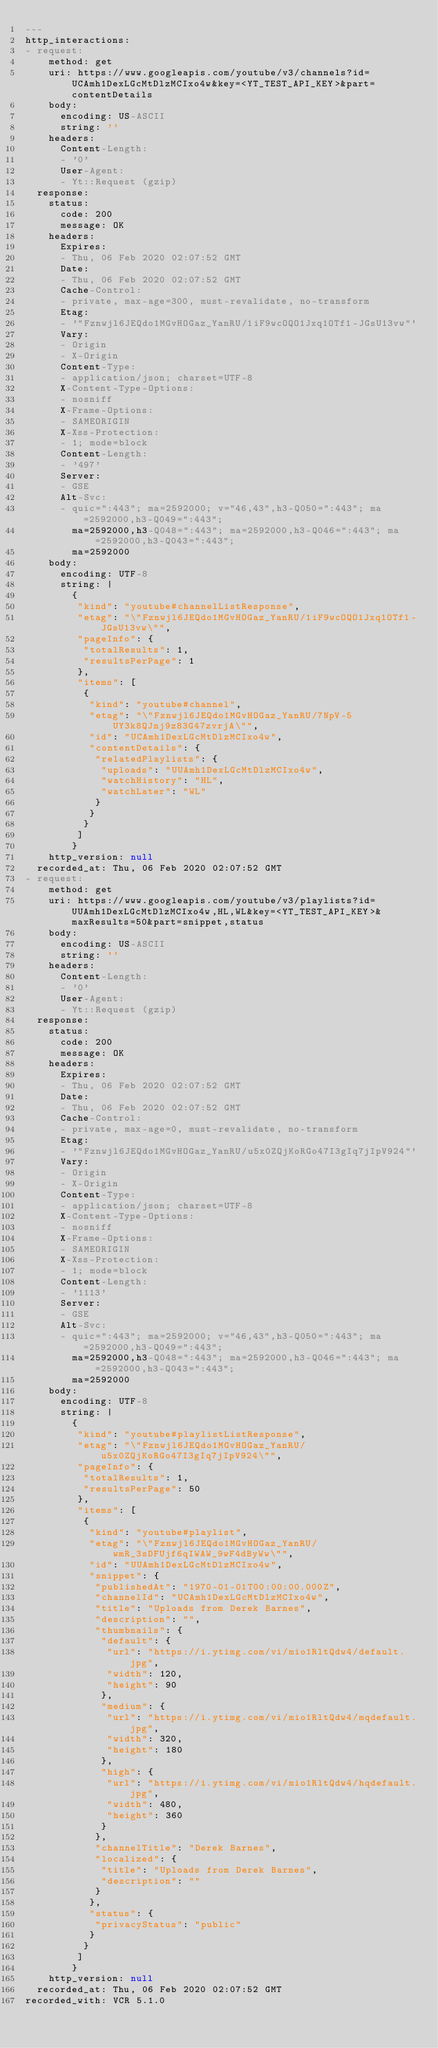<code> <loc_0><loc_0><loc_500><loc_500><_YAML_>---
http_interactions:
- request:
    method: get
    uri: https://www.googleapis.com/youtube/v3/channels?id=UCAmh1DexLGcMtDlzMCIxo4w&key=<YT_TEST_API_KEY>&part=contentDetails
    body:
      encoding: US-ASCII
      string: ''
    headers:
      Content-Length:
      - '0'
      User-Agent:
      - Yt::Request (gzip)
  response:
    status:
      code: 200
      message: OK
    headers:
      Expires:
      - Thu, 06 Feb 2020 02:07:52 GMT
      Date:
      - Thu, 06 Feb 2020 02:07:52 GMT
      Cache-Control:
      - private, max-age=300, must-revalidate, no-transform
      Etag:
      - '"Fznwjl6JEQdo1MGvHOGaz_YanRU/1iF9wcOQO1Jxq1OTf1-JGsU13vw"'
      Vary:
      - Origin
      - X-Origin
      Content-Type:
      - application/json; charset=UTF-8
      X-Content-Type-Options:
      - nosniff
      X-Frame-Options:
      - SAMEORIGIN
      X-Xss-Protection:
      - 1; mode=block
      Content-Length:
      - '497'
      Server:
      - GSE
      Alt-Svc:
      - quic=":443"; ma=2592000; v="46,43",h3-Q050=":443"; ma=2592000,h3-Q049=":443";
        ma=2592000,h3-Q048=":443"; ma=2592000,h3-Q046=":443"; ma=2592000,h3-Q043=":443";
        ma=2592000
    body:
      encoding: UTF-8
      string: |
        {
         "kind": "youtube#channelListResponse",
         "etag": "\"Fznwjl6JEQdo1MGvHOGaz_YanRU/1iF9wcOQO1Jxq1OTf1-JGsU13vw\"",
         "pageInfo": {
          "totalResults": 1,
          "resultsPerPage": 1
         },
         "items": [
          {
           "kind": "youtube#channel",
           "etag": "\"Fznwjl6JEQdo1MGvHOGaz_YanRU/7NpV-5UY3k8QJnj9z83G47zvrjA\"",
           "id": "UCAmh1DexLGcMtDlzMCIxo4w",
           "contentDetails": {
            "relatedPlaylists": {
             "uploads": "UUAmh1DexLGcMtDlzMCIxo4w",
             "watchHistory": "HL",
             "watchLater": "WL"
            }
           }
          }
         ]
        }
    http_version: null
  recorded_at: Thu, 06 Feb 2020 02:07:52 GMT
- request:
    method: get
    uri: https://www.googleapis.com/youtube/v3/playlists?id=UUAmh1DexLGcMtDlzMCIxo4w,HL,WL&key=<YT_TEST_API_KEY>&maxResults=50&part=snippet,status
    body:
      encoding: US-ASCII
      string: ''
    headers:
      Content-Length:
      - '0'
      User-Agent:
      - Yt::Request (gzip)
  response:
    status:
      code: 200
      message: OK
    headers:
      Expires:
      - Thu, 06 Feb 2020 02:07:52 GMT
      Date:
      - Thu, 06 Feb 2020 02:07:52 GMT
      Cache-Control:
      - private, max-age=0, must-revalidate, no-transform
      Etag:
      - '"Fznwjl6JEQdo1MGvHOGaz_YanRU/u5x0ZQjKoRGo47I3gIq7jIpV924"'
      Vary:
      - Origin
      - X-Origin
      Content-Type:
      - application/json; charset=UTF-8
      X-Content-Type-Options:
      - nosniff
      X-Frame-Options:
      - SAMEORIGIN
      X-Xss-Protection:
      - 1; mode=block
      Content-Length:
      - '1113'
      Server:
      - GSE
      Alt-Svc:
      - quic=":443"; ma=2592000; v="46,43",h3-Q050=":443"; ma=2592000,h3-Q049=":443";
        ma=2592000,h3-Q048=":443"; ma=2592000,h3-Q046=":443"; ma=2592000,h3-Q043=":443";
        ma=2592000
    body:
      encoding: UTF-8
      string: |
        {
         "kind": "youtube#playlistListResponse",
         "etag": "\"Fznwjl6JEQdo1MGvHOGaz_YanRU/u5x0ZQjKoRGo47I3gIq7jIpV924\"",
         "pageInfo": {
          "totalResults": 1,
          "resultsPerPage": 50
         },
         "items": [
          {
           "kind": "youtube#playlist",
           "etag": "\"Fznwjl6JEQdo1MGvHOGaz_YanRU/wmR_3sDFUjf6qIWAW_9wF4dByWw\"",
           "id": "UUAmh1DexLGcMtDlzMCIxo4w",
           "snippet": {
            "publishedAt": "1970-01-01T00:00:00.000Z",
            "channelId": "UCAmh1DexLGcMtDlzMCIxo4w",
            "title": "Uploads from Derek Barnes",
            "description": "",
            "thumbnails": {
             "default": {
              "url": "https://i.ytimg.com/vi/mio1RltQdw4/default.jpg",
              "width": 120,
              "height": 90
             },
             "medium": {
              "url": "https://i.ytimg.com/vi/mio1RltQdw4/mqdefault.jpg",
              "width": 320,
              "height": 180
             },
             "high": {
              "url": "https://i.ytimg.com/vi/mio1RltQdw4/hqdefault.jpg",
              "width": 480,
              "height": 360
             }
            },
            "channelTitle": "Derek Barnes",
            "localized": {
             "title": "Uploads from Derek Barnes",
             "description": ""
            }
           },
           "status": {
            "privacyStatus": "public"
           }
          }
         ]
        }
    http_version: null
  recorded_at: Thu, 06 Feb 2020 02:07:52 GMT
recorded_with: VCR 5.1.0
</code> 